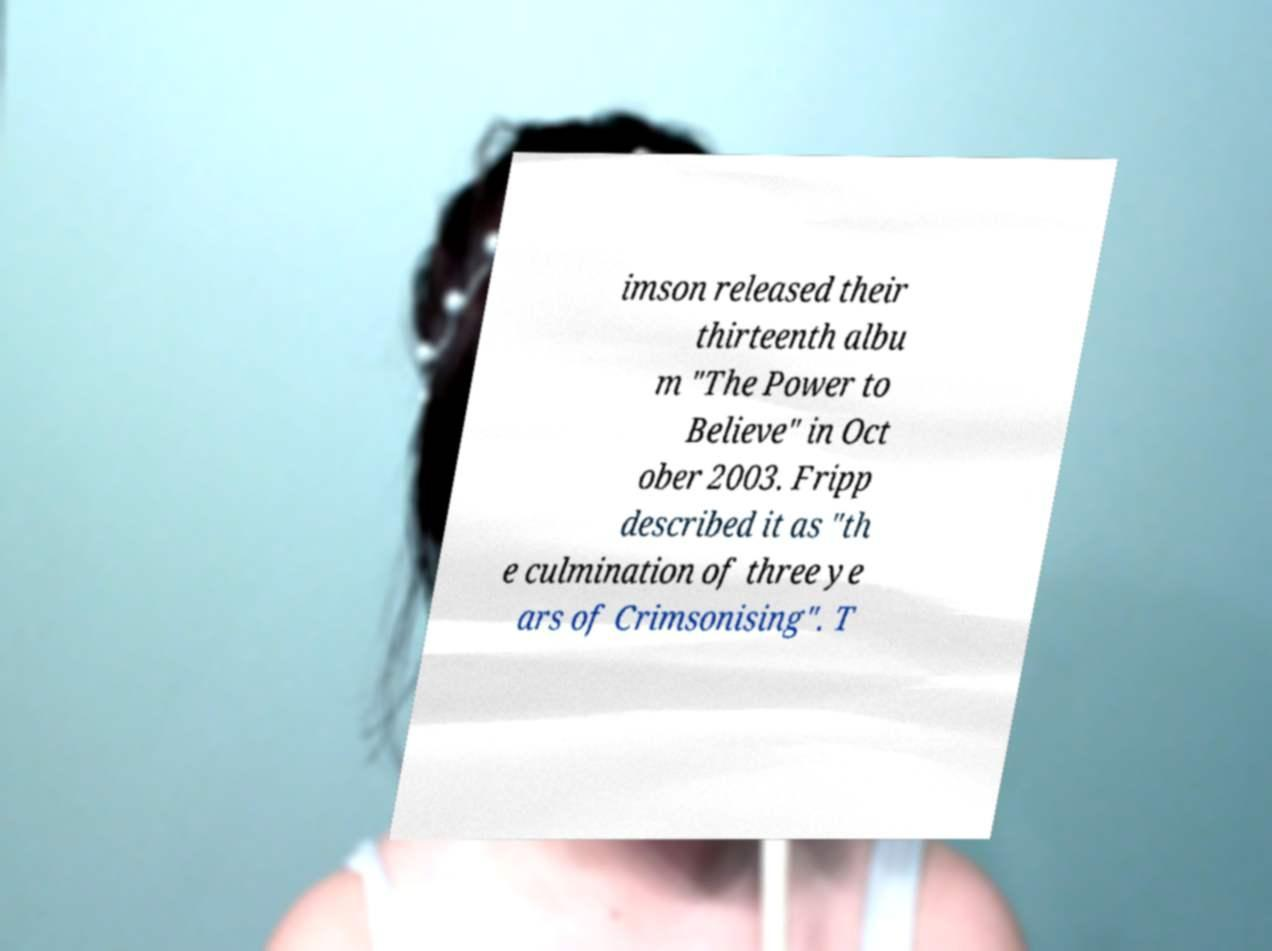What messages or text are displayed in this image? I need them in a readable, typed format. imson released their thirteenth albu m "The Power to Believe" in Oct ober 2003. Fripp described it as "th e culmination of three ye ars of Crimsonising". T 